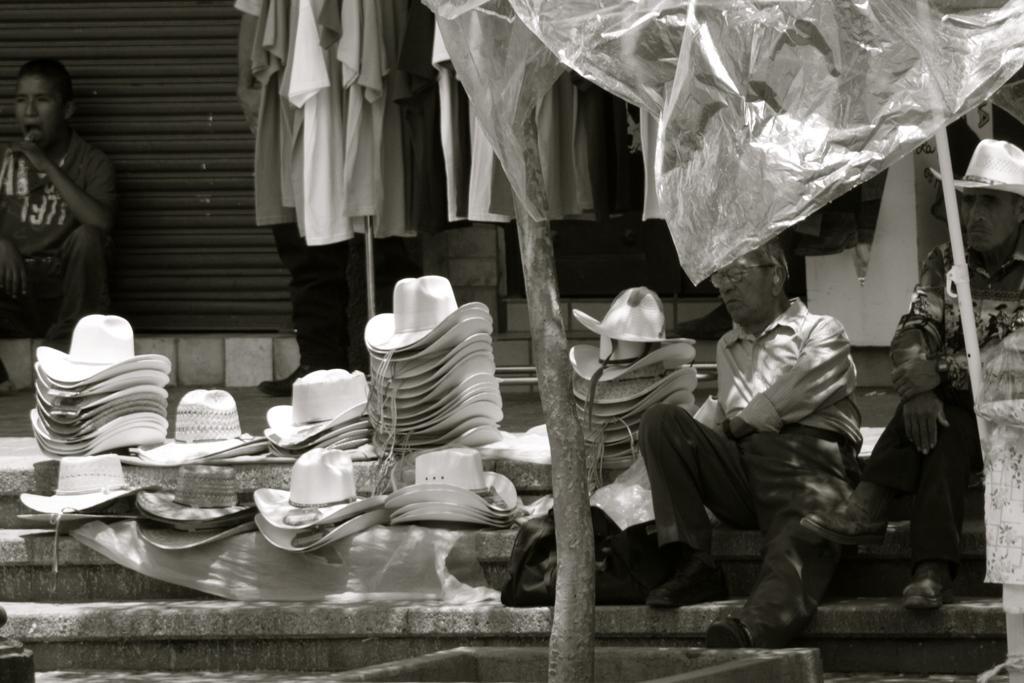In one or two sentences, can you explain what this image depicts? This is a black and white image. In this image we can see persons sitting on the stairs, hats, store and polythene covers. 